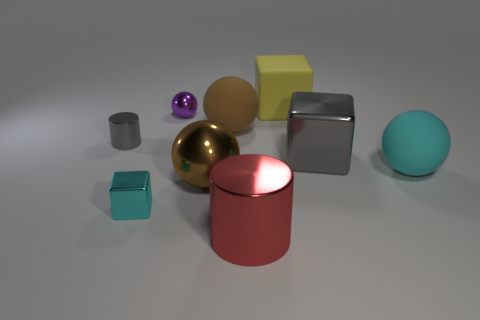What might be the purpose of this image? This image appears to be a rendered 3D composition, designed to showcase a variety of geometric shapes and materials. It could serve numerous purposes: as a visual exercise in understanding forms and perspective, for artistic appreciation, or as an asset in a graphical library for practice, testing, or demonstration of rendering techniques. 